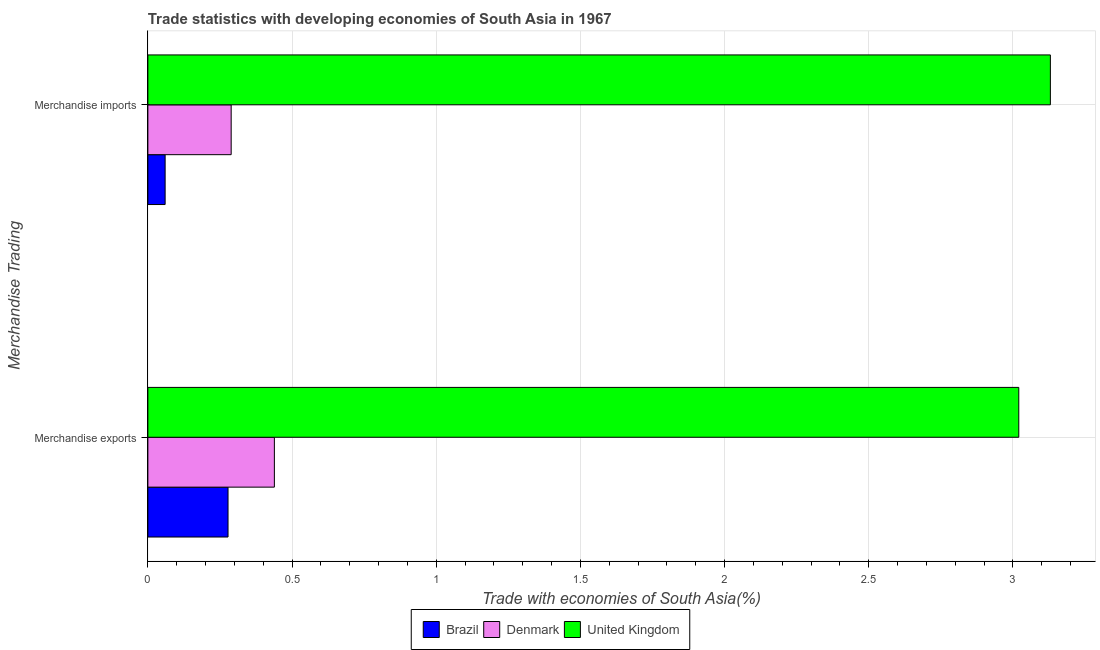How many groups of bars are there?
Your answer should be very brief. 2. How many bars are there on the 2nd tick from the bottom?
Provide a short and direct response. 3. What is the merchandise imports in Brazil?
Make the answer very short. 0.06. Across all countries, what is the maximum merchandise exports?
Offer a very short reply. 3.02. Across all countries, what is the minimum merchandise exports?
Ensure brevity in your answer.  0.28. In which country was the merchandise exports maximum?
Make the answer very short. United Kingdom. What is the total merchandise exports in the graph?
Offer a terse response. 3.74. What is the difference between the merchandise exports in Brazil and that in United Kingdom?
Keep it short and to the point. -2.74. What is the difference between the merchandise imports in Denmark and the merchandise exports in United Kingdom?
Provide a succinct answer. -2.73. What is the average merchandise exports per country?
Your answer should be compact. 1.25. What is the difference between the merchandise imports and merchandise exports in Denmark?
Make the answer very short. -0.15. What is the ratio of the merchandise imports in Denmark to that in Brazil?
Provide a succinct answer. 4.83. In how many countries, is the merchandise imports greater than the average merchandise imports taken over all countries?
Give a very brief answer. 1. What does the 1st bar from the top in Merchandise imports represents?
Provide a short and direct response. United Kingdom. Are all the bars in the graph horizontal?
Keep it short and to the point. Yes. What is the difference between two consecutive major ticks on the X-axis?
Ensure brevity in your answer.  0.5. Are the values on the major ticks of X-axis written in scientific E-notation?
Ensure brevity in your answer.  No. Does the graph contain any zero values?
Keep it short and to the point. No. How many legend labels are there?
Your answer should be very brief. 3. How are the legend labels stacked?
Your answer should be compact. Horizontal. What is the title of the graph?
Your answer should be very brief. Trade statistics with developing economies of South Asia in 1967. Does "Yemen, Rep." appear as one of the legend labels in the graph?
Offer a very short reply. No. What is the label or title of the X-axis?
Offer a very short reply. Trade with economies of South Asia(%). What is the label or title of the Y-axis?
Your answer should be compact. Merchandise Trading. What is the Trade with economies of South Asia(%) in Brazil in Merchandise exports?
Give a very brief answer. 0.28. What is the Trade with economies of South Asia(%) of Denmark in Merchandise exports?
Offer a terse response. 0.44. What is the Trade with economies of South Asia(%) of United Kingdom in Merchandise exports?
Provide a short and direct response. 3.02. What is the Trade with economies of South Asia(%) of Brazil in Merchandise imports?
Your answer should be compact. 0.06. What is the Trade with economies of South Asia(%) in Denmark in Merchandise imports?
Offer a terse response. 0.29. What is the Trade with economies of South Asia(%) in United Kingdom in Merchandise imports?
Provide a succinct answer. 3.13. Across all Merchandise Trading, what is the maximum Trade with economies of South Asia(%) in Brazil?
Provide a succinct answer. 0.28. Across all Merchandise Trading, what is the maximum Trade with economies of South Asia(%) of Denmark?
Offer a very short reply. 0.44. Across all Merchandise Trading, what is the maximum Trade with economies of South Asia(%) in United Kingdom?
Your answer should be very brief. 3.13. Across all Merchandise Trading, what is the minimum Trade with economies of South Asia(%) of Brazil?
Offer a very short reply. 0.06. Across all Merchandise Trading, what is the minimum Trade with economies of South Asia(%) of Denmark?
Offer a very short reply. 0.29. Across all Merchandise Trading, what is the minimum Trade with economies of South Asia(%) of United Kingdom?
Give a very brief answer. 3.02. What is the total Trade with economies of South Asia(%) of Brazil in the graph?
Your response must be concise. 0.34. What is the total Trade with economies of South Asia(%) of Denmark in the graph?
Provide a short and direct response. 0.73. What is the total Trade with economies of South Asia(%) in United Kingdom in the graph?
Provide a succinct answer. 6.15. What is the difference between the Trade with economies of South Asia(%) in Brazil in Merchandise exports and that in Merchandise imports?
Give a very brief answer. 0.22. What is the difference between the Trade with economies of South Asia(%) of Denmark in Merchandise exports and that in Merchandise imports?
Provide a short and direct response. 0.15. What is the difference between the Trade with economies of South Asia(%) of United Kingdom in Merchandise exports and that in Merchandise imports?
Provide a succinct answer. -0.11. What is the difference between the Trade with economies of South Asia(%) of Brazil in Merchandise exports and the Trade with economies of South Asia(%) of Denmark in Merchandise imports?
Provide a succinct answer. -0.01. What is the difference between the Trade with economies of South Asia(%) of Brazil in Merchandise exports and the Trade with economies of South Asia(%) of United Kingdom in Merchandise imports?
Offer a terse response. -2.85. What is the difference between the Trade with economies of South Asia(%) of Denmark in Merchandise exports and the Trade with economies of South Asia(%) of United Kingdom in Merchandise imports?
Offer a very short reply. -2.69. What is the average Trade with economies of South Asia(%) in Brazil per Merchandise Trading?
Your answer should be very brief. 0.17. What is the average Trade with economies of South Asia(%) in Denmark per Merchandise Trading?
Make the answer very short. 0.36. What is the average Trade with economies of South Asia(%) in United Kingdom per Merchandise Trading?
Offer a terse response. 3.08. What is the difference between the Trade with economies of South Asia(%) in Brazil and Trade with economies of South Asia(%) in Denmark in Merchandise exports?
Your response must be concise. -0.16. What is the difference between the Trade with economies of South Asia(%) in Brazil and Trade with economies of South Asia(%) in United Kingdom in Merchandise exports?
Provide a succinct answer. -2.74. What is the difference between the Trade with economies of South Asia(%) in Denmark and Trade with economies of South Asia(%) in United Kingdom in Merchandise exports?
Offer a terse response. -2.58. What is the difference between the Trade with economies of South Asia(%) of Brazil and Trade with economies of South Asia(%) of Denmark in Merchandise imports?
Provide a succinct answer. -0.23. What is the difference between the Trade with economies of South Asia(%) of Brazil and Trade with economies of South Asia(%) of United Kingdom in Merchandise imports?
Ensure brevity in your answer.  -3.07. What is the difference between the Trade with economies of South Asia(%) of Denmark and Trade with economies of South Asia(%) of United Kingdom in Merchandise imports?
Give a very brief answer. -2.84. What is the ratio of the Trade with economies of South Asia(%) in Brazil in Merchandise exports to that in Merchandise imports?
Offer a terse response. 4.64. What is the ratio of the Trade with economies of South Asia(%) in Denmark in Merchandise exports to that in Merchandise imports?
Offer a terse response. 1.52. What is the ratio of the Trade with economies of South Asia(%) in United Kingdom in Merchandise exports to that in Merchandise imports?
Offer a terse response. 0.96. What is the difference between the highest and the second highest Trade with economies of South Asia(%) of Brazil?
Make the answer very short. 0.22. What is the difference between the highest and the second highest Trade with economies of South Asia(%) in Denmark?
Make the answer very short. 0.15. What is the difference between the highest and the second highest Trade with economies of South Asia(%) of United Kingdom?
Give a very brief answer. 0.11. What is the difference between the highest and the lowest Trade with economies of South Asia(%) of Brazil?
Offer a very short reply. 0.22. What is the difference between the highest and the lowest Trade with economies of South Asia(%) of Denmark?
Keep it short and to the point. 0.15. What is the difference between the highest and the lowest Trade with economies of South Asia(%) in United Kingdom?
Keep it short and to the point. 0.11. 